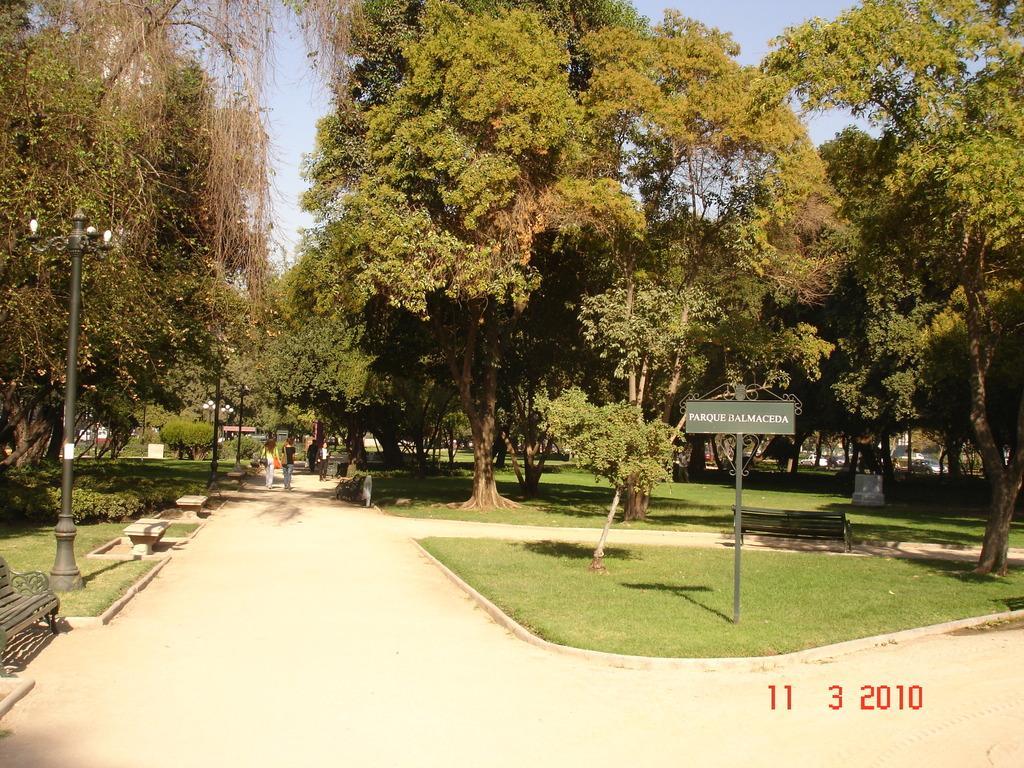Can you describe this image briefly? In this image few persons are on the path. Left side there is a street light on the grass land. Left side there are few benches. Right side there is a board attached to the pole. Background there are few plants and trees on the grassland. Top of the image there is sky. 